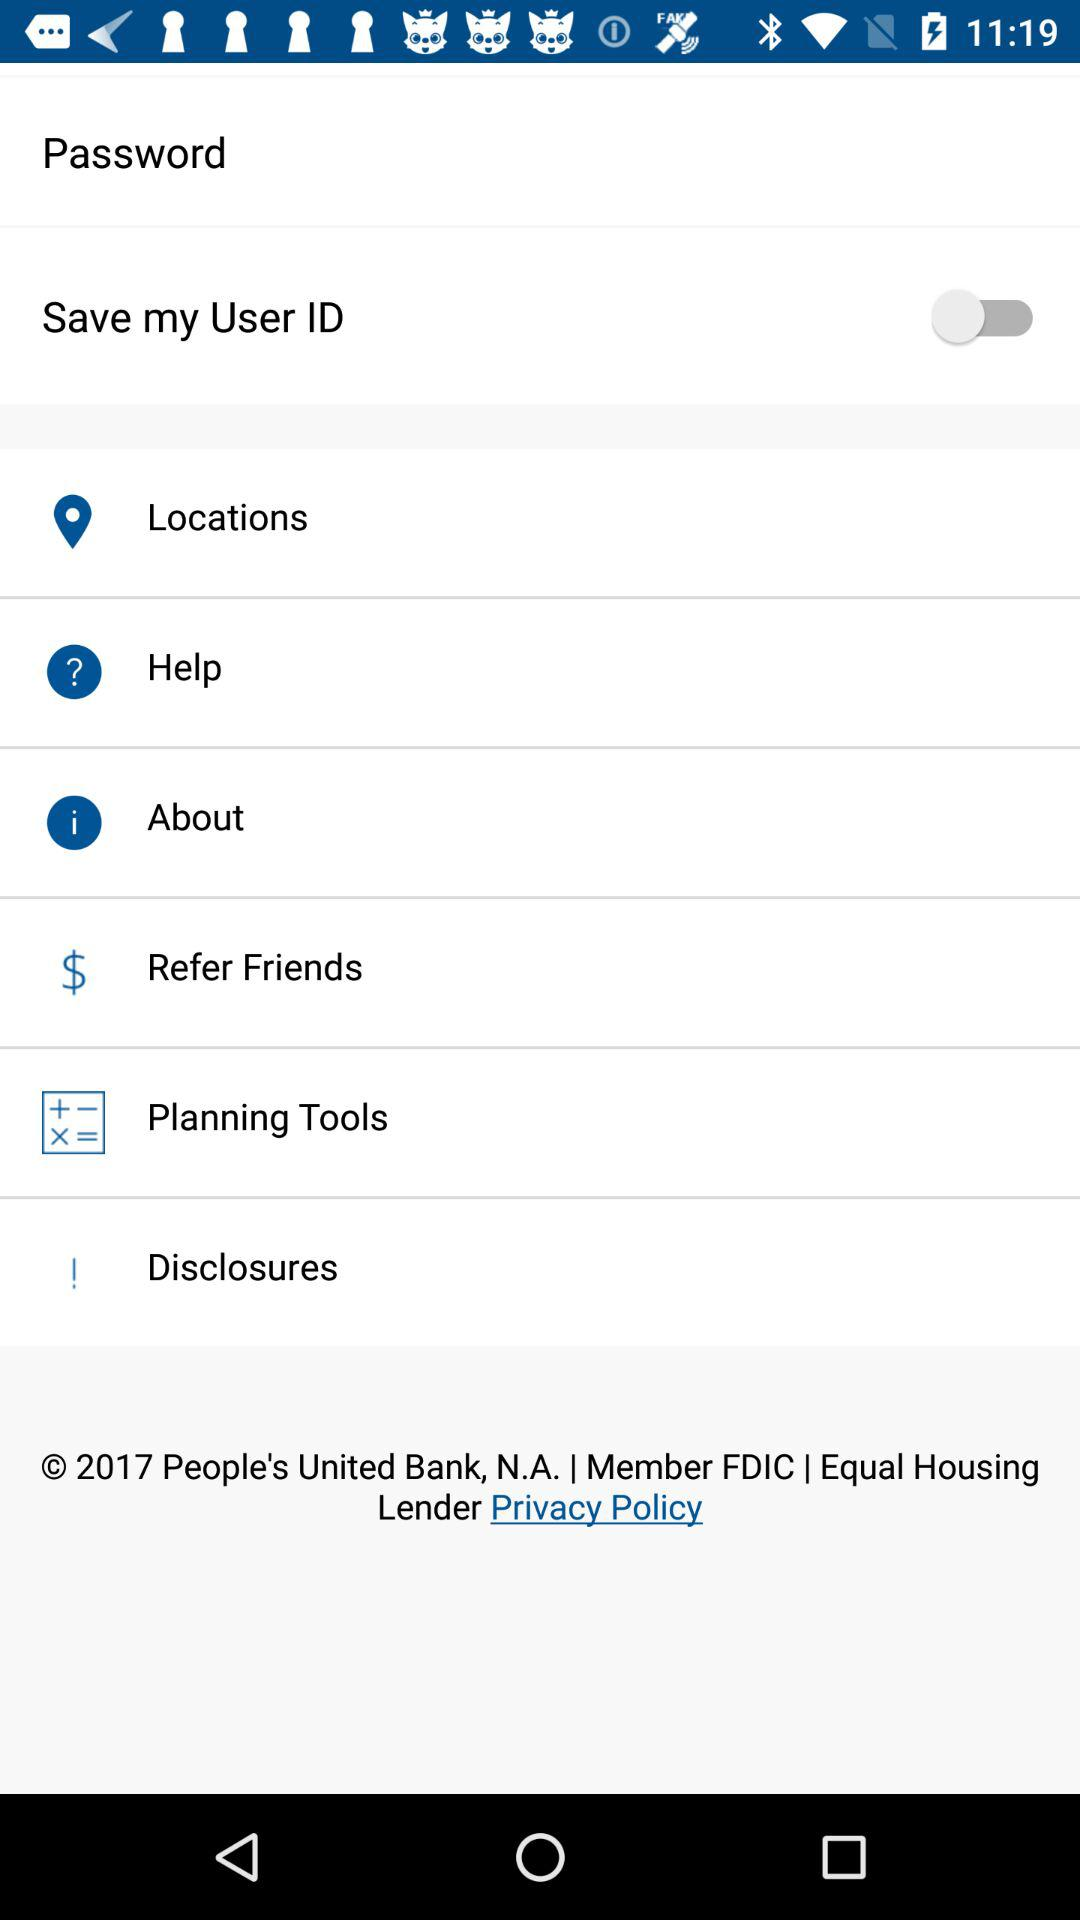What is the status of the "Save my User ID"? The status is "off". 